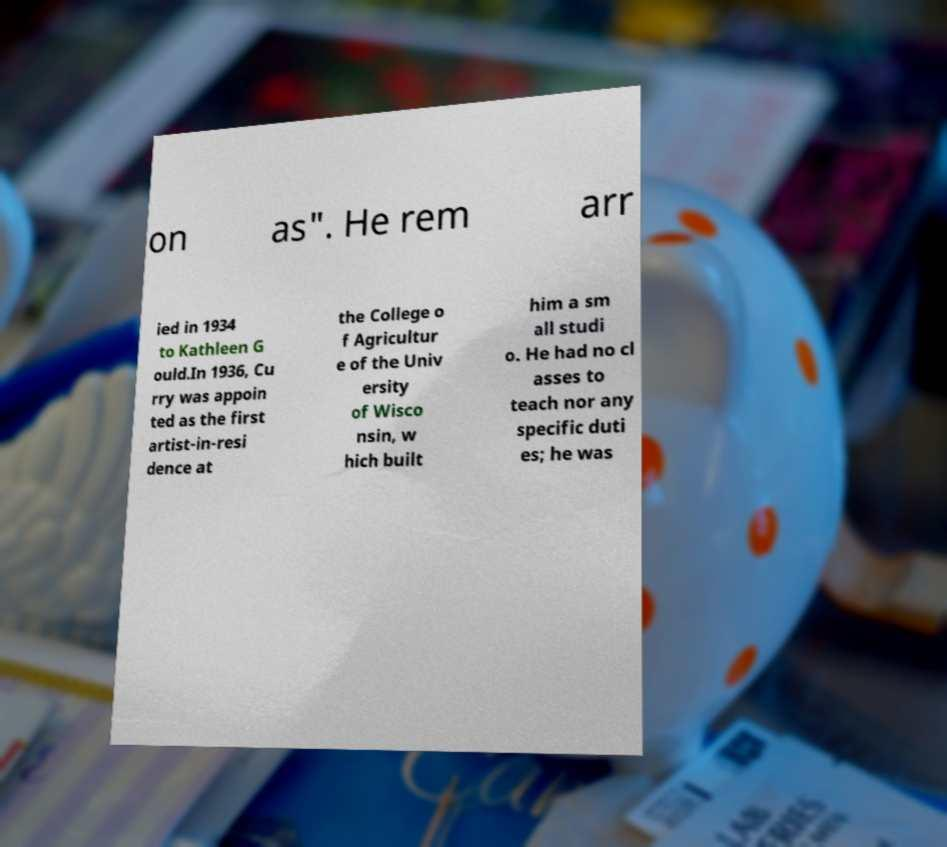Please identify and transcribe the text found in this image. on as". He rem arr ied in 1934 to Kathleen G ould.In 1936, Cu rry was appoin ted as the first artist-in-resi dence at the College o f Agricultur e of the Univ ersity of Wisco nsin, w hich built him a sm all studi o. He had no cl asses to teach nor any specific duti es; he was 